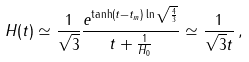<formula> <loc_0><loc_0><loc_500><loc_500>H ( t ) \simeq \frac { 1 } { \sqrt { 3 } } \frac { e ^ { \tanh ( t - t _ { m } ) \ln \sqrt { \frac { 4 } { 3 } } } } { t + \frac { 1 } { H _ { 0 } } } \simeq \frac { 1 } { \sqrt { 3 } t } \, ,</formula> 